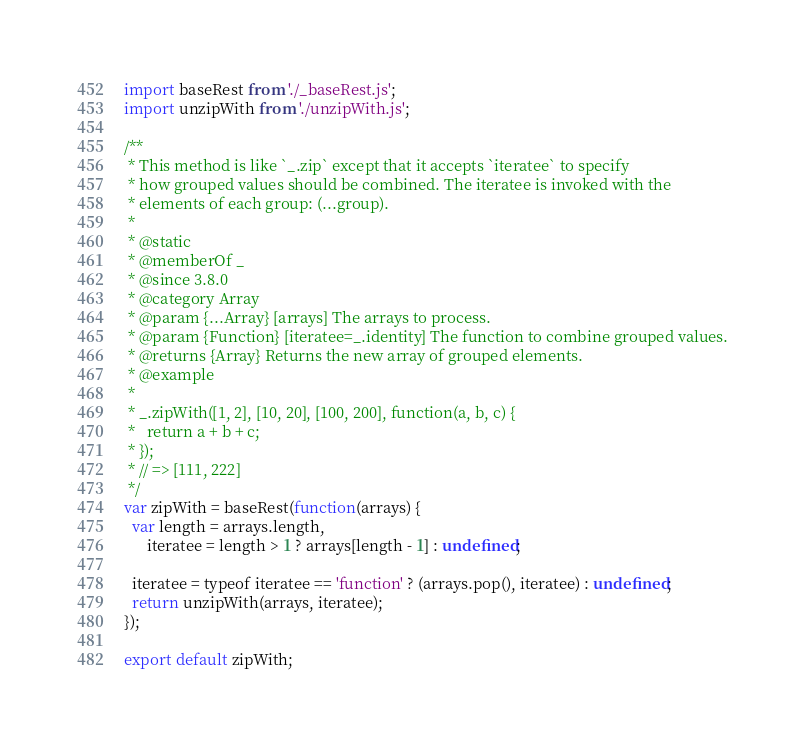<code> <loc_0><loc_0><loc_500><loc_500><_JavaScript_>import baseRest from './_baseRest.js';
import unzipWith from './unzipWith.js';

/**
 * This method is like `_.zip` except that it accepts `iteratee` to specify
 * how grouped values should be combined. The iteratee is invoked with the
 * elements of each group: (...group).
 *
 * @static
 * @memberOf _
 * @since 3.8.0
 * @category Array
 * @param {...Array} [arrays] The arrays to process.
 * @param {Function} [iteratee=_.identity] The function to combine grouped values.
 * @returns {Array} Returns the new array of grouped elements.
 * @example
 *
 * _.zipWith([1, 2], [10, 20], [100, 200], function(a, b, c) {
 *   return a + b + c;
 * });
 * // => [111, 222]
 */
var zipWith = baseRest(function(arrays) {
  var length = arrays.length,
      iteratee = length > 1 ? arrays[length - 1] : undefined;

  iteratee = typeof iteratee == 'function' ? (arrays.pop(), iteratee) : undefined;
  return unzipWith(arrays, iteratee);
});

export default zipWith;
</code> 